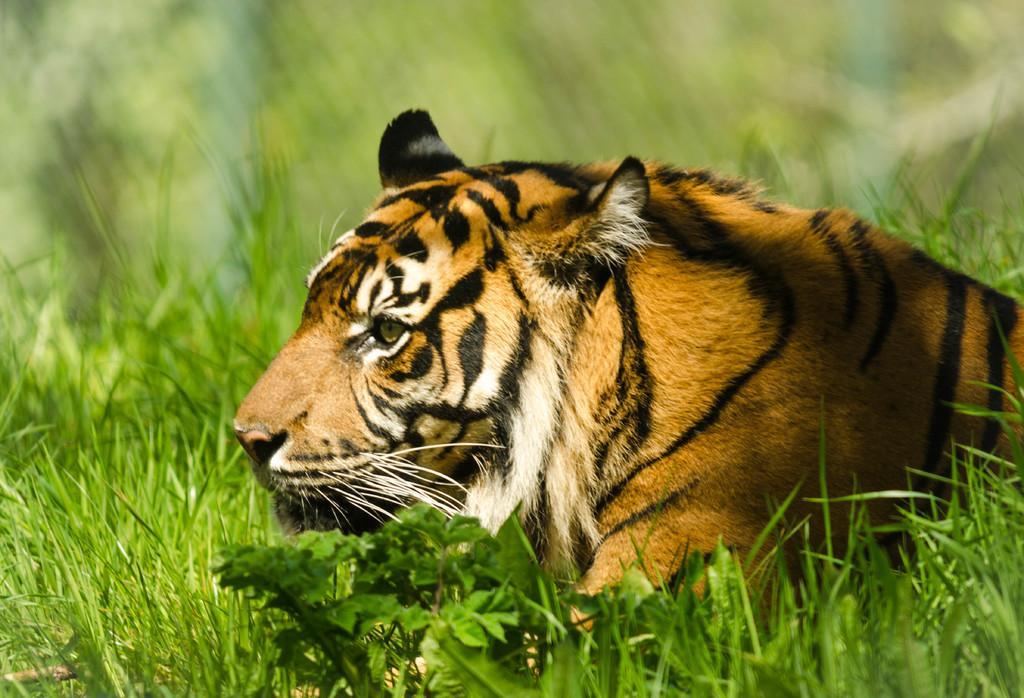Describe this image in one or two sentences. In this picture we can see a tiger, leaves and grass. In the background of the image it is blurry. 